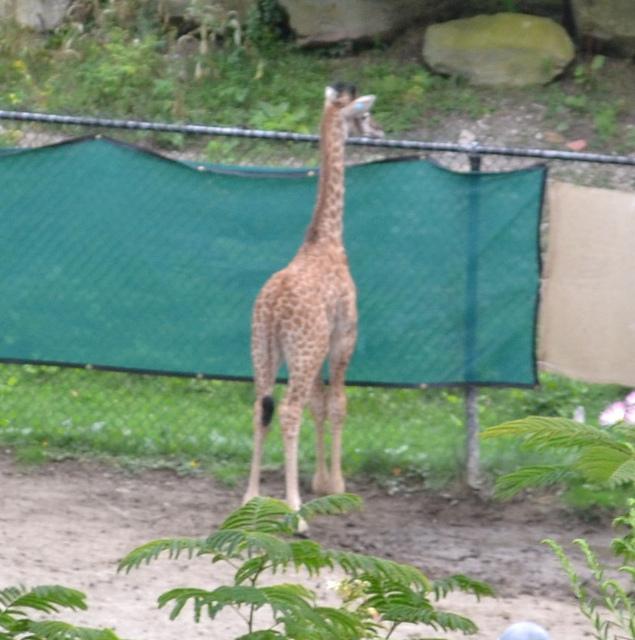What color is the giraffe?
Quick response, please. Orange. What is on the fence?
Keep it brief. Tarp. Does this animal have a tail?
Concise answer only. Yes. How many legs does this animal have?
Keep it brief. 4. 